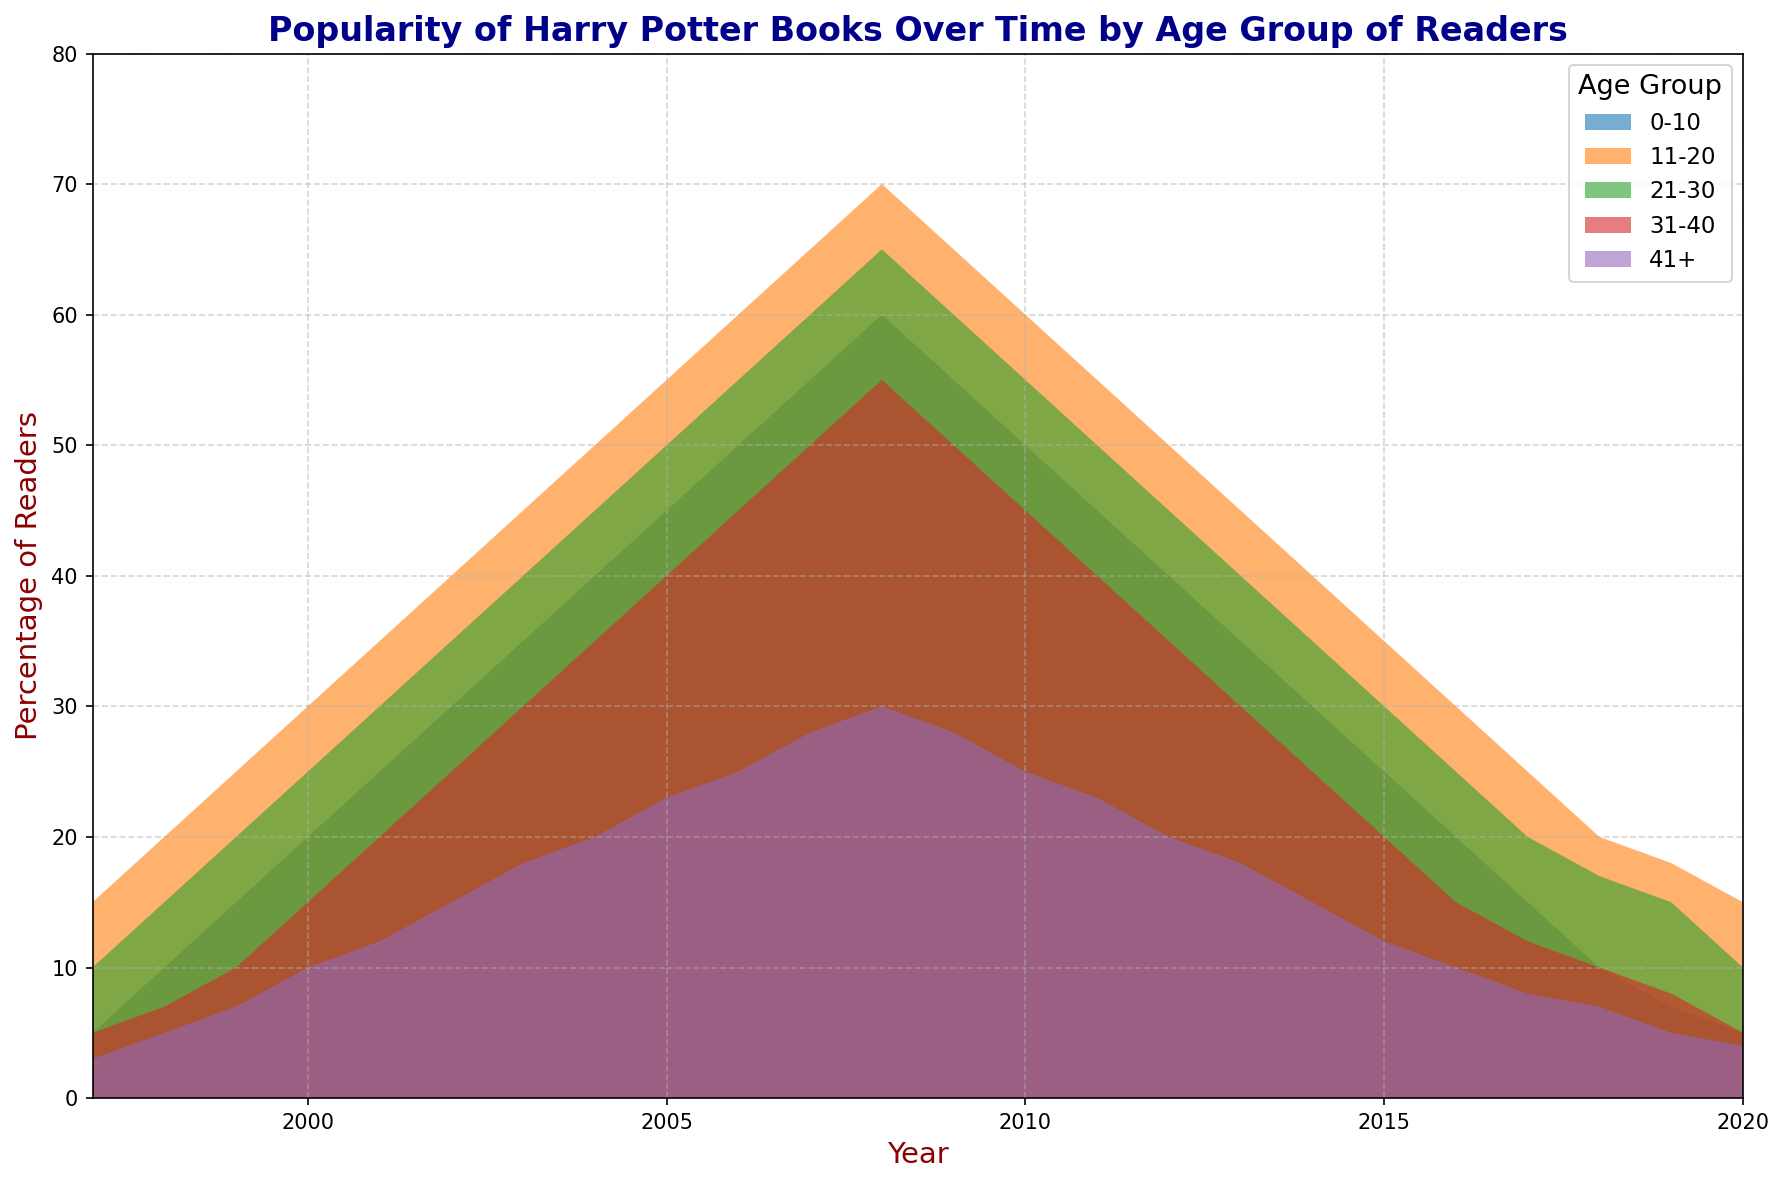What age group had the highest percentage of readers in 2007? In the year 2007, observe the heights of the filled areas representing different age groups. The 11-20 age group reaches the highest point in 2007.
Answer: 11-20 Which age group showed a decline in popularity after 2008? Look at the trends after 2008 for each age group. The 0-10 age group, 11-20 age group, 21-30 age group, and 41+ age group all show a decline in popularity after 2008.
Answer: 0-10, 11-20, 21-30, 41+ In 2004, what is the combined percentage of readers for the 21-30 and 31-40 age groups? In 2004, the percentage for the 21-30 age group is 45% and for the 31-40 age group is 35%. Adding them gives 45 + 35.
Answer: 80% Which age group consistently had the lowest percentage of readers over the years? Examine the bottom-most filled area along the x-axis (years). The 41+ age group consistently had the lowest percentage of readers throughout the timeline.
Answer: 41+ In what year did the 0-10 and 11-20 age groups both reach their peak percentages? Check the areas to find the peak heights for both the 0-10 and 11-20 age groups. Both groups reached their peak percentages in 2008.
Answer: 2008 How did the percentage of readers for the 21-30 age group change between 1997 and 2010? The percentage of readers for the 21-30 age group increased from 10% in 1997 to 55% in 2010.
Answer: Increased What is the average percentage of readers for the 31-40 age group from 1997 to 2004? Sum the percentages for the 31-40 age group from 1997 to 2004 and divide by the number of years. (5 + 7 + 10 + 15 + 20 + 25 + 30 + 35) / 8 = 18.375.
Answer: 18.375 Which age group showed the fastest increase in popularity from 2000 to 2005? From 2000 to 2005, examine the slopes of the filled areas. The 0-10 age group had an increase from 20% to 45%, the fastest increase among all groups.
Answer: 0-10 In which year did the 41+ age group first exceed 20% readers? Look at when the filled area for the 41+ age group first goes above the 20% line. This happens in 2005.
Answer: 2005 What was the percentage drop for the 11-20 age group from 2008 to 2010? The percentage for the 11-20 age group dropped from 70% in 2008 to 60% in 2010. The drop is 70 - 60.
Answer: 10% 